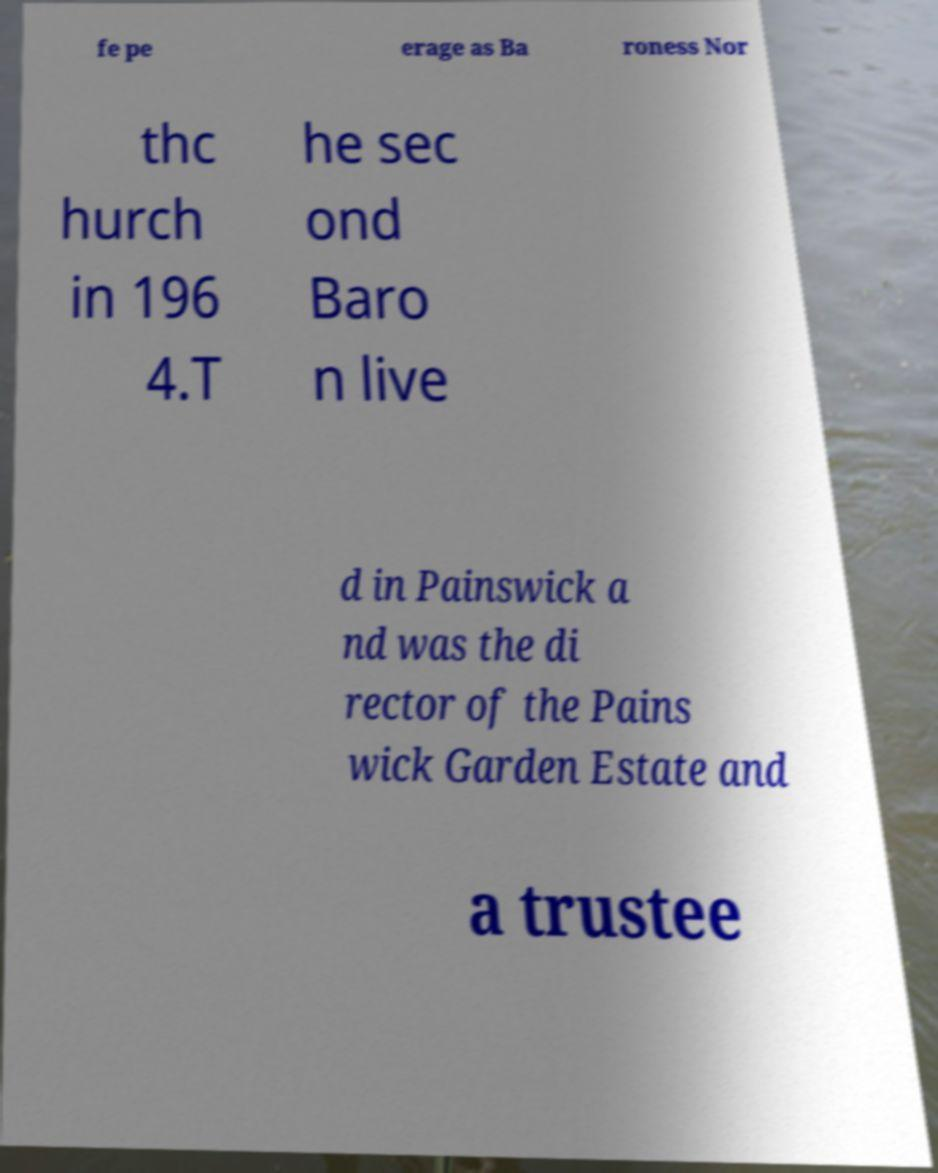Please read and relay the text visible in this image. What does it say? fe pe erage as Ba roness Nor thc hurch in 196 4.T he sec ond Baro n live d in Painswick a nd was the di rector of the Pains wick Garden Estate and a trustee 